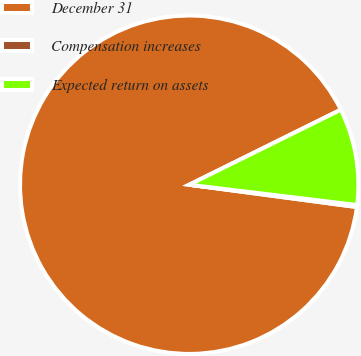<chart> <loc_0><loc_0><loc_500><loc_500><pie_chart><fcel>December 31<fcel>Compensation increases<fcel>Expected return on assets<nl><fcel>90.58%<fcel>0.19%<fcel>9.23%<nl></chart> 